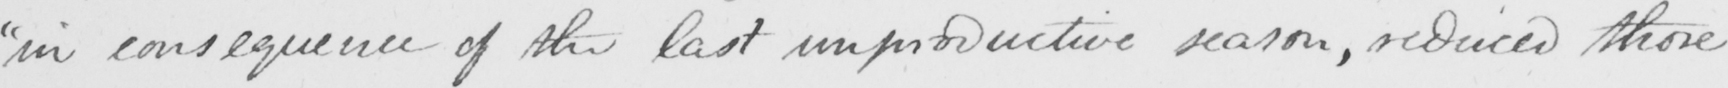Transcribe the text shown in this historical manuscript line. " in consequence of the last unproductive season , reduced those 